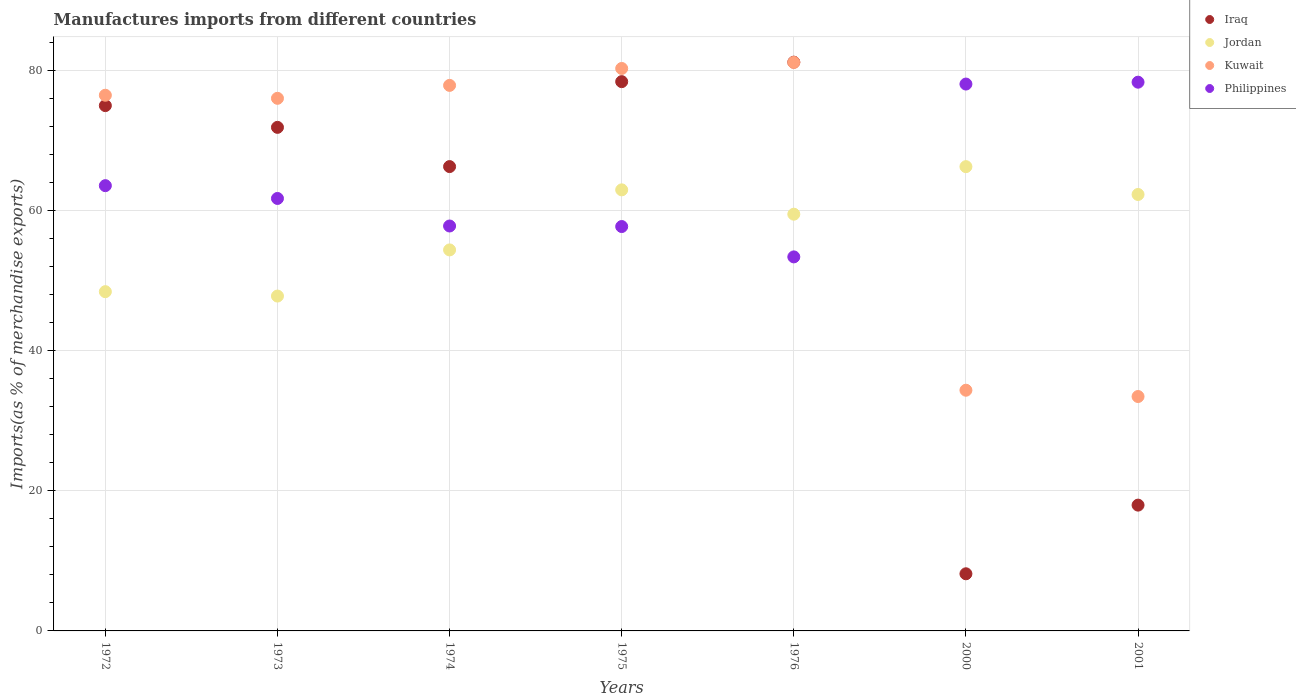How many different coloured dotlines are there?
Make the answer very short. 4. Is the number of dotlines equal to the number of legend labels?
Make the answer very short. Yes. What is the percentage of imports to different countries in Philippines in 2000?
Offer a very short reply. 78.01. Across all years, what is the maximum percentage of imports to different countries in Philippines?
Keep it short and to the point. 78.28. Across all years, what is the minimum percentage of imports to different countries in Kuwait?
Keep it short and to the point. 33.44. In which year was the percentage of imports to different countries in Jordan minimum?
Your response must be concise. 1973. What is the total percentage of imports to different countries in Kuwait in the graph?
Your response must be concise. 459.33. What is the difference between the percentage of imports to different countries in Philippines in 1974 and that in 1976?
Offer a very short reply. 4.41. What is the difference between the percentage of imports to different countries in Philippines in 1973 and the percentage of imports to different countries in Jordan in 1975?
Ensure brevity in your answer.  -1.23. What is the average percentage of imports to different countries in Philippines per year?
Make the answer very short. 64.33. In the year 1976, what is the difference between the percentage of imports to different countries in Iraq and percentage of imports to different countries in Kuwait?
Offer a terse response. 0.04. What is the ratio of the percentage of imports to different countries in Jordan in 1973 to that in 2001?
Offer a terse response. 0.77. Is the difference between the percentage of imports to different countries in Iraq in 1973 and 1976 greater than the difference between the percentage of imports to different countries in Kuwait in 1973 and 1976?
Offer a terse response. No. What is the difference between the highest and the second highest percentage of imports to different countries in Kuwait?
Offer a very short reply. 0.86. What is the difference between the highest and the lowest percentage of imports to different countries in Iraq?
Give a very brief answer. 72.99. Does the percentage of imports to different countries in Iraq monotonically increase over the years?
Your response must be concise. No. Is the percentage of imports to different countries in Iraq strictly greater than the percentage of imports to different countries in Kuwait over the years?
Give a very brief answer. No. Are the values on the major ticks of Y-axis written in scientific E-notation?
Provide a succinct answer. No. Does the graph contain grids?
Give a very brief answer. Yes. How many legend labels are there?
Offer a terse response. 4. How are the legend labels stacked?
Ensure brevity in your answer.  Vertical. What is the title of the graph?
Provide a succinct answer. Manufactures imports from different countries. What is the label or title of the Y-axis?
Your answer should be compact. Imports(as % of merchandise exports). What is the Imports(as % of merchandise exports) in Iraq in 1972?
Provide a short and direct response. 74.94. What is the Imports(as % of merchandise exports) of Jordan in 1972?
Your response must be concise. 48.4. What is the Imports(as % of merchandise exports) in Kuwait in 1972?
Make the answer very short. 76.42. What is the Imports(as % of merchandise exports) of Philippines in 1972?
Make the answer very short. 63.52. What is the Imports(as % of merchandise exports) in Iraq in 1973?
Give a very brief answer. 71.84. What is the Imports(as % of merchandise exports) of Jordan in 1973?
Keep it short and to the point. 47.77. What is the Imports(as % of merchandise exports) of Kuwait in 1973?
Ensure brevity in your answer.  75.98. What is the Imports(as % of merchandise exports) in Philippines in 1973?
Keep it short and to the point. 61.69. What is the Imports(as % of merchandise exports) in Iraq in 1974?
Your answer should be compact. 66.24. What is the Imports(as % of merchandise exports) in Jordan in 1974?
Offer a very short reply. 54.35. What is the Imports(as % of merchandise exports) in Kuwait in 1974?
Give a very brief answer. 77.82. What is the Imports(as % of merchandise exports) in Philippines in 1974?
Offer a very short reply. 57.76. What is the Imports(as % of merchandise exports) of Iraq in 1975?
Your response must be concise. 78.36. What is the Imports(as % of merchandise exports) of Jordan in 1975?
Offer a terse response. 62.92. What is the Imports(as % of merchandise exports) of Kuwait in 1975?
Offer a very short reply. 80.24. What is the Imports(as % of merchandise exports) of Philippines in 1975?
Keep it short and to the point. 57.69. What is the Imports(as % of merchandise exports) of Iraq in 1976?
Your response must be concise. 81.14. What is the Imports(as % of merchandise exports) of Jordan in 1976?
Your response must be concise. 59.45. What is the Imports(as % of merchandise exports) in Kuwait in 1976?
Your answer should be very brief. 81.1. What is the Imports(as % of merchandise exports) of Philippines in 1976?
Provide a succinct answer. 53.36. What is the Imports(as % of merchandise exports) of Iraq in 2000?
Your response must be concise. 8.15. What is the Imports(as % of merchandise exports) of Jordan in 2000?
Your answer should be compact. 66.23. What is the Imports(as % of merchandise exports) of Kuwait in 2000?
Give a very brief answer. 34.34. What is the Imports(as % of merchandise exports) in Philippines in 2000?
Offer a very short reply. 78.01. What is the Imports(as % of merchandise exports) in Iraq in 2001?
Ensure brevity in your answer.  17.95. What is the Imports(as % of merchandise exports) of Jordan in 2001?
Give a very brief answer. 62.26. What is the Imports(as % of merchandise exports) of Kuwait in 2001?
Offer a very short reply. 33.44. What is the Imports(as % of merchandise exports) in Philippines in 2001?
Provide a succinct answer. 78.28. Across all years, what is the maximum Imports(as % of merchandise exports) in Iraq?
Give a very brief answer. 81.14. Across all years, what is the maximum Imports(as % of merchandise exports) in Jordan?
Your answer should be very brief. 66.23. Across all years, what is the maximum Imports(as % of merchandise exports) in Kuwait?
Offer a very short reply. 81.1. Across all years, what is the maximum Imports(as % of merchandise exports) in Philippines?
Offer a very short reply. 78.28. Across all years, what is the minimum Imports(as % of merchandise exports) of Iraq?
Provide a succinct answer. 8.15. Across all years, what is the minimum Imports(as % of merchandise exports) in Jordan?
Your answer should be compact. 47.77. Across all years, what is the minimum Imports(as % of merchandise exports) of Kuwait?
Make the answer very short. 33.44. Across all years, what is the minimum Imports(as % of merchandise exports) of Philippines?
Give a very brief answer. 53.36. What is the total Imports(as % of merchandise exports) in Iraq in the graph?
Your response must be concise. 398.61. What is the total Imports(as % of merchandise exports) of Jordan in the graph?
Your answer should be compact. 401.38. What is the total Imports(as % of merchandise exports) in Kuwait in the graph?
Keep it short and to the point. 459.33. What is the total Imports(as % of merchandise exports) of Philippines in the graph?
Your response must be concise. 450.32. What is the difference between the Imports(as % of merchandise exports) of Iraq in 1972 and that in 1973?
Give a very brief answer. 3.1. What is the difference between the Imports(as % of merchandise exports) of Jordan in 1972 and that in 1973?
Give a very brief answer. 0.63. What is the difference between the Imports(as % of merchandise exports) of Kuwait in 1972 and that in 1973?
Ensure brevity in your answer.  0.44. What is the difference between the Imports(as % of merchandise exports) of Philippines in 1972 and that in 1973?
Offer a terse response. 1.83. What is the difference between the Imports(as % of merchandise exports) of Iraq in 1972 and that in 1974?
Offer a very short reply. 8.7. What is the difference between the Imports(as % of merchandise exports) of Jordan in 1972 and that in 1974?
Ensure brevity in your answer.  -5.96. What is the difference between the Imports(as % of merchandise exports) of Kuwait in 1972 and that in 1974?
Your answer should be compact. -1.41. What is the difference between the Imports(as % of merchandise exports) in Philippines in 1972 and that in 1974?
Provide a short and direct response. 5.75. What is the difference between the Imports(as % of merchandise exports) in Iraq in 1972 and that in 1975?
Provide a short and direct response. -3.42. What is the difference between the Imports(as % of merchandise exports) of Jordan in 1972 and that in 1975?
Your response must be concise. -14.52. What is the difference between the Imports(as % of merchandise exports) of Kuwait in 1972 and that in 1975?
Ensure brevity in your answer.  -3.82. What is the difference between the Imports(as % of merchandise exports) in Philippines in 1972 and that in 1975?
Your answer should be very brief. 5.83. What is the difference between the Imports(as % of merchandise exports) in Iraq in 1972 and that in 1976?
Your answer should be compact. -6.2. What is the difference between the Imports(as % of merchandise exports) in Jordan in 1972 and that in 1976?
Give a very brief answer. -11.05. What is the difference between the Imports(as % of merchandise exports) of Kuwait in 1972 and that in 1976?
Make the answer very short. -4.68. What is the difference between the Imports(as % of merchandise exports) in Philippines in 1972 and that in 1976?
Ensure brevity in your answer.  10.16. What is the difference between the Imports(as % of merchandise exports) of Iraq in 1972 and that in 2000?
Make the answer very short. 66.79. What is the difference between the Imports(as % of merchandise exports) of Jordan in 1972 and that in 2000?
Offer a very short reply. -17.84. What is the difference between the Imports(as % of merchandise exports) of Kuwait in 1972 and that in 2000?
Offer a terse response. 42.08. What is the difference between the Imports(as % of merchandise exports) of Philippines in 1972 and that in 2000?
Your answer should be very brief. -14.49. What is the difference between the Imports(as % of merchandise exports) of Iraq in 1972 and that in 2001?
Ensure brevity in your answer.  56.99. What is the difference between the Imports(as % of merchandise exports) of Jordan in 1972 and that in 2001?
Make the answer very short. -13.86. What is the difference between the Imports(as % of merchandise exports) in Kuwait in 1972 and that in 2001?
Give a very brief answer. 42.98. What is the difference between the Imports(as % of merchandise exports) in Philippines in 1972 and that in 2001?
Give a very brief answer. -14.76. What is the difference between the Imports(as % of merchandise exports) in Iraq in 1973 and that in 1974?
Provide a succinct answer. 5.6. What is the difference between the Imports(as % of merchandise exports) of Jordan in 1973 and that in 1974?
Give a very brief answer. -6.58. What is the difference between the Imports(as % of merchandise exports) of Kuwait in 1973 and that in 1974?
Provide a succinct answer. -1.84. What is the difference between the Imports(as % of merchandise exports) of Philippines in 1973 and that in 1974?
Ensure brevity in your answer.  3.93. What is the difference between the Imports(as % of merchandise exports) of Iraq in 1973 and that in 1975?
Make the answer very short. -6.52. What is the difference between the Imports(as % of merchandise exports) in Jordan in 1973 and that in 1975?
Make the answer very short. -15.15. What is the difference between the Imports(as % of merchandise exports) in Kuwait in 1973 and that in 1975?
Your answer should be very brief. -4.26. What is the difference between the Imports(as % of merchandise exports) in Philippines in 1973 and that in 1975?
Offer a very short reply. 4.01. What is the difference between the Imports(as % of merchandise exports) of Iraq in 1973 and that in 1976?
Offer a terse response. -9.3. What is the difference between the Imports(as % of merchandise exports) in Jordan in 1973 and that in 1976?
Ensure brevity in your answer.  -11.68. What is the difference between the Imports(as % of merchandise exports) in Kuwait in 1973 and that in 1976?
Provide a short and direct response. -5.12. What is the difference between the Imports(as % of merchandise exports) of Philippines in 1973 and that in 1976?
Your response must be concise. 8.34. What is the difference between the Imports(as % of merchandise exports) in Iraq in 1973 and that in 2000?
Keep it short and to the point. 63.69. What is the difference between the Imports(as % of merchandise exports) of Jordan in 1973 and that in 2000?
Your response must be concise. -18.46. What is the difference between the Imports(as % of merchandise exports) in Kuwait in 1973 and that in 2000?
Make the answer very short. 41.64. What is the difference between the Imports(as % of merchandise exports) of Philippines in 1973 and that in 2000?
Your answer should be very brief. -16.32. What is the difference between the Imports(as % of merchandise exports) in Iraq in 1973 and that in 2001?
Offer a very short reply. 53.89. What is the difference between the Imports(as % of merchandise exports) in Jordan in 1973 and that in 2001?
Ensure brevity in your answer.  -14.49. What is the difference between the Imports(as % of merchandise exports) of Kuwait in 1973 and that in 2001?
Provide a short and direct response. 42.54. What is the difference between the Imports(as % of merchandise exports) in Philippines in 1973 and that in 2001?
Your answer should be compact. -16.59. What is the difference between the Imports(as % of merchandise exports) in Iraq in 1974 and that in 1975?
Your answer should be compact. -12.12. What is the difference between the Imports(as % of merchandise exports) in Jordan in 1974 and that in 1975?
Your response must be concise. -8.57. What is the difference between the Imports(as % of merchandise exports) of Kuwait in 1974 and that in 1975?
Offer a terse response. -2.41. What is the difference between the Imports(as % of merchandise exports) in Philippines in 1974 and that in 1975?
Offer a very short reply. 0.08. What is the difference between the Imports(as % of merchandise exports) in Iraq in 1974 and that in 1976?
Provide a succinct answer. -14.9. What is the difference between the Imports(as % of merchandise exports) of Jordan in 1974 and that in 1976?
Keep it short and to the point. -5.1. What is the difference between the Imports(as % of merchandise exports) in Kuwait in 1974 and that in 1976?
Your answer should be compact. -3.27. What is the difference between the Imports(as % of merchandise exports) in Philippines in 1974 and that in 1976?
Make the answer very short. 4.41. What is the difference between the Imports(as % of merchandise exports) of Iraq in 1974 and that in 2000?
Your answer should be compact. 58.09. What is the difference between the Imports(as % of merchandise exports) in Jordan in 1974 and that in 2000?
Provide a succinct answer. -11.88. What is the difference between the Imports(as % of merchandise exports) of Kuwait in 1974 and that in 2000?
Give a very brief answer. 43.49. What is the difference between the Imports(as % of merchandise exports) of Philippines in 1974 and that in 2000?
Offer a very short reply. -20.25. What is the difference between the Imports(as % of merchandise exports) of Iraq in 1974 and that in 2001?
Keep it short and to the point. 48.29. What is the difference between the Imports(as % of merchandise exports) of Jordan in 1974 and that in 2001?
Your answer should be very brief. -7.91. What is the difference between the Imports(as % of merchandise exports) of Kuwait in 1974 and that in 2001?
Your response must be concise. 44.38. What is the difference between the Imports(as % of merchandise exports) of Philippines in 1974 and that in 2001?
Make the answer very short. -20.52. What is the difference between the Imports(as % of merchandise exports) of Iraq in 1975 and that in 1976?
Give a very brief answer. -2.78. What is the difference between the Imports(as % of merchandise exports) of Jordan in 1975 and that in 1976?
Offer a very short reply. 3.47. What is the difference between the Imports(as % of merchandise exports) in Kuwait in 1975 and that in 1976?
Provide a succinct answer. -0.86. What is the difference between the Imports(as % of merchandise exports) of Philippines in 1975 and that in 1976?
Your response must be concise. 4.33. What is the difference between the Imports(as % of merchandise exports) of Iraq in 1975 and that in 2000?
Give a very brief answer. 70.21. What is the difference between the Imports(as % of merchandise exports) in Jordan in 1975 and that in 2000?
Give a very brief answer. -3.31. What is the difference between the Imports(as % of merchandise exports) in Kuwait in 1975 and that in 2000?
Give a very brief answer. 45.9. What is the difference between the Imports(as % of merchandise exports) in Philippines in 1975 and that in 2000?
Offer a terse response. -20.33. What is the difference between the Imports(as % of merchandise exports) of Iraq in 1975 and that in 2001?
Keep it short and to the point. 60.41. What is the difference between the Imports(as % of merchandise exports) of Jordan in 1975 and that in 2001?
Your answer should be compact. 0.66. What is the difference between the Imports(as % of merchandise exports) of Kuwait in 1975 and that in 2001?
Offer a very short reply. 46.8. What is the difference between the Imports(as % of merchandise exports) in Philippines in 1975 and that in 2001?
Offer a very short reply. -20.59. What is the difference between the Imports(as % of merchandise exports) in Iraq in 1976 and that in 2000?
Ensure brevity in your answer.  72.99. What is the difference between the Imports(as % of merchandise exports) in Jordan in 1976 and that in 2000?
Keep it short and to the point. -6.78. What is the difference between the Imports(as % of merchandise exports) of Kuwait in 1976 and that in 2000?
Give a very brief answer. 46.76. What is the difference between the Imports(as % of merchandise exports) in Philippines in 1976 and that in 2000?
Your answer should be compact. -24.66. What is the difference between the Imports(as % of merchandise exports) in Iraq in 1976 and that in 2001?
Keep it short and to the point. 63.19. What is the difference between the Imports(as % of merchandise exports) of Jordan in 1976 and that in 2001?
Ensure brevity in your answer.  -2.81. What is the difference between the Imports(as % of merchandise exports) of Kuwait in 1976 and that in 2001?
Give a very brief answer. 47.66. What is the difference between the Imports(as % of merchandise exports) in Philippines in 1976 and that in 2001?
Provide a succinct answer. -24.92. What is the difference between the Imports(as % of merchandise exports) in Iraq in 2000 and that in 2001?
Offer a terse response. -9.79. What is the difference between the Imports(as % of merchandise exports) in Jordan in 2000 and that in 2001?
Your answer should be very brief. 3.97. What is the difference between the Imports(as % of merchandise exports) of Kuwait in 2000 and that in 2001?
Your answer should be compact. 0.9. What is the difference between the Imports(as % of merchandise exports) in Philippines in 2000 and that in 2001?
Ensure brevity in your answer.  -0.27. What is the difference between the Imports(as % of merchandise exports) in Iraq in 1972 and the Imports(as % of merchandise exports) in Jordan in 1973?
Make the answer very short. 27.17. What is the difference between the Imports(as % of merchandise exports) of Iraq in 1972 and the Imports(as % of merchandise exports) of Kuwait in 1973?
Offer a very short reply. -1.04. What is the difference between the Imports(as % of merchandise exports) of Iraq in 1972 and the Imports(as % of merchandise exports) of Philippines in 1973?
Give a very brief answer. 13.24. What is the difference between the Imports(as % of merchandise exports) in Jordan in 1972 and the Imports(as % of merchandise exports) in Kuwait in 1973?
Give a very brief answer. -27.58. What is the difference between the Imports(as % of merchandise exports) of Jordan in 1972 and the Imports(as % of merchandise exports) of Philippines in 1973?
Offer a terse response. -13.3. What is the difference between the Imports(as % of merchandise exports) of Kuwait in 1972 and the Imports(as % of merchandise exports) of Philippines in 1973?
Keep it short and to the point. 14.72. What is the difference between the Imports(as % of merchandise exports) in Iraq in 1972 and the Imports(as % of merchandise exports) in Jordan in 1974?
Your answer should be very brief. 20.59. What is the difference between the Imports(as % of merchandise exports) in Iraq in 1972 and the Imports(as % of merchandise exports) in Kuwait in 1974?
Your response must be concise. -2.88. What is the difference between the Imports(as % of merchandise exports) of Iraq in 1972 and the Imports(as % of merchandise exports) of Philippines in 1974?
Offer a terse response. 17.17. What is the difference between the Imports(as % of merchandise exports) of Jordan in 1972 and the Imports(as % of merchandise exports) of Kuwait in 1974?
Provide a short and direct response. -29.43. What is the difference between the Imports(as % of merchandise exports) in Jordan in 1972 and the Imports(as % of merchandise exports) in Philippines in 1974?
Offer a very short reply. -9.37. What is the difference between the Imports(as % of merchandise exports) of Kuwait in 1972 and the Imports(as % of merchandise exports) of Philippines in 1974?
Your response must be concise. 18.65. What is the difference between the Imports(as % of merchandise exports) of Iraq in 1972 and the Imports(as % of merchandise exports) of Jordan in 1975?
Provide a succinct answer. 12.02. What is the difference between the Imports(as % of merchandise exports) in Iraq in 1972 and the Imports(as % of merchandise exports) in Kuwait in 1975?
Make the answer very short. -5.3. What is the difference between the Imports(as % of merchandise exports) of Iraq in 1972 and the Imports(as % of merchandise exports) of Philippines in 1975?
Provide a succinct answer. 17.25. What is the difference between the Imports(as % of merchandise exports) in Jordan in 1972 and the Imports(as % of merchandise exports) in Kuwait in 1975?
Your response must be concise. -31.84. What is the difference between the Imports(as % of merchandise exports) in Jordan in 1972 and the Imports(as % of merchandise exports) in Philippines in 1975?
Make the answer very short. -9.29. What is the difference between the Imports(as % of merchandise exports) in Kuwait in 1972 and the Imports(as % of merchandise exports) in Philippines in 1975?
Ensure brevity in your answer.  18.73. What is the difference between the Imports(as % of merchandise exports) of Iraq in 1972 and the Imports(as % of merchandise exports) of Jordan in 1976?
Offer a terse response. 15.49. What is the difference between the Imports(as % of merchandise exports) of Iraq in 1972 and the Imports(as % of merchandise exports) of Kuwait in 1976?
Your answer should be very brief. -6.16. What is the difference between the Imports(as % of merchandise exports) in Iraq in 1972 and the Imports(as % of merchandise exports) in Philippines in 1976?
Provide a short and direct response. 21.58. What is the difference between the Imports(as % of merchandise exports) of Jordan in 1972 and the Imports(as % of merchandise exports) of Kuwait in 1976?
Your response must be concise. -32.7. What is the difference between the Imports(as % of merchandise exports) of Jordan in 1972 and the Imports(as % of merchandise exports) of Philippines in 1976?
Your response must be concise. -4.96. What is the difference between the Imports(as % of merchandise exports) of Kuwait in 1972 and the Imports(as % of merchandise exports) of Philippines in 1976?
Ensure brevity in your answer.  23.06. What is the difference between the Imports(as % of merchandise exports) in Iraq in 1972 and the Imports(as % of merchandise exports) in Jordan in 2000?
Your answer should be very brief. 8.71. What is the difference between the Imports(as % of merchandise exports) in Iraq in 1972 and the Imports(as % of merchandise exports) in Kuwait in 2000?
Your answer should be compact. 40.6. What is the difference between the Imports(as % of merchandise exports) in Iraq in 1972 and the Imports(as % of merchandise exports) in Philippines in 2000?
Keep it short and to the point. -3.07. What is the difference between the Imports(as % of merchandise exports) of Jordan in 1972 and the Imports(as % of merchandise exports) of Kuwait in 2000?
Give a very brief answer. 14.06. What is the difference between the Imports(as % of merchandise exports) of Jordan in 1972 and the Imports(as % of merchandise exports) of Philippines in 2000?
Ensure brevity in your answer.  -29.62. What is the difference between the Imports(as % of merchandise exports) of Kuwait in 1972 and the Imports(as % of merchandise exports) of Philippines in 2000?
Ensure brevity in your answer.  -1.6. What is the difference between the Imports(as % of merchandise exports) in Iraq in 1972 and the Imports(as % of merchandise exports) in Jordan in 2001?
Offer a terse response. 12.68. What is the difference between the Imports(as % of merchandise exports) of Iraq in 1972 and the Imports(as % of merchandise exports) of Kuwait in 2001?
Make the answer very short. 41.5. What is the difference between the Imports(as % of merchandise exports) in Iraq in 1972 and the Imports(as % of merchandise exports) in Philippines in 2001?
Give a very brief answer. -3.34. What is the difference between the Imports(as % of merchandise exports) of Jordan in 1972 and the Imports(as % of merchandise exports) of Kuwait in 2001?
Ensure brevity in your answer.  14.96. What is the difference between the Imports(as % of merchandise exports) in Jordan in 1972 and the Imports(as % of merchandise exports) in Philippines in 2001?
Ensure brevity in your answer.  -29.88. What is the difference between the Imports(as % of merchandise exports) of Kuwait in 1972 and the Imports(as % of merchandise exports) of Philippines in 2001?
Provide a succinct answer. -1.86. What is the difference between the Imports(as % of merchandise exports) in Iraq in 1973 and the Imports(as % of merchandise exports) in Jordan in 1974?
Give a very brief answer. 17.48. What is the difference between the Imports(as % of merchandise exports) in Iraq in 1973 and the Imports(as % of merchandise exports) in Kuwait in 1974?
Offer a terse response. -5.99. What is the difference between the Imports(as % of merchandise exports) in Iraq in 1973 and the Imports(as % of merchandise exports) in Philippines in 1974?
Ensure brevity in your answer.  14.07. What is the difference between the Imports(as % of merchandise exports) of Jordan in 1973 and the Imports(as % of merchandise exports) of Kuwait in 1974?
Your response must be concise. -30.05. What is the difference between the Imports(as % of merchandise exports) of Jordan in 1973 and the Imports(as % of merchandise exports) of Philippines in 1974?
Give a very brief answer. -9.99. What is the difference between the Imports(as % of merchandise exports) of Kuwait in 1973 and the Imports(as % of merchandise exports) of Philippines in 1974?
Your answer should be very brief. 18.22. What is the difference between the Imports(as % of merchandise exports) of Iraq in 1973 and the Imports(as % of merchandise exports) of Jordan in 1975?
Offer a very short reply. 8.92. What is the difference between the Imports(as % of merchandise exports) of Iraq in 1973 and the Imports(as % of merchandise exports) of Kuwait in 1975?
Ensure brevity in your answer.  -8.4. What is the difference between the Imports(as % of merchandise exports) in Iraq in 1973 and the Imports(as % of merchandise exports) in Philippines in 1975?
Keep it short and to the point. 14.15. What is the difference between the Imports(as % of merchandise exports) of Jordan in 1973 and the Imports(as % of merchandise exports) of Kuwait in 1975?
Keep it short and to the point. -32.47. What is the difference between the Imports(as % of merchandise exports) of Jordan in 1973 and the Imports(as % of merchandise exports) of Philippines in 1975?
Give a very brief answer. -9.92. What is the difference between the Imports(as % of merchandise exports) of Kuwait in 1973 and the Imports(as % of merchandise exports) of Philippines in 1975?
Make the answer very short. 18.29. What is the difference between the Imports(as % of merchandise exports) of Iraq in 1973 and the Imports(as % of merchandise exports) of Jordan in 1976?
Your response must be concise. 12.39. What is the difference between the Imports(as % of merchandise exports) of Iraq in 1973 and the Imports(as % of merchandise exports) of Kuwait in 1976?
Give a very brief answer. -9.26. What is the difference between the Imports(as % of merchandise exports) in Iraq in 1973 and the Imports(as % of merchandise exports) in Philippines in 1976?
Keep it short and to the point. 18.48. What is the difference between the Imports(as % of merchandise exports) in Jordan in 1973 and the Imports(as % of merchandise exports) in Kuwait in 1976?
Your answer should be very brief. -33.33. What is the difference between the Imports(as % of merchandise exports) in Jordan in 1973 and the Imports(as % of merchandise exports) in Philippines in 1976?
Your answer should be compact. -5.59. What is the difference between the Imports(as % of merchandise exports) of Kuwait in 1973 and the Imports(as % of merchandise exports) of Philippines in 1976?
Your answer should be very brief. 22.62. What is the difference between the Imports(as % of merchandise exports) of Iraq in 1973 and the Imports(as % of merchandise exports) of Jordan in 2000?
Your answer should be compact. 5.6. What is the difference between the Imports(as % of merchandise exports) of Iraq in 1973 and the Imports(as % of merchandise exports) of Kuwait in 2000?
Your answer should be compact. 37.5. What is the difference between the Imports(as % of merchandise exports) of Iraq in 1973 and the Imports(as % of merchandise exports) of Philippines in 2000?
Your answer should be compact. -6.18. What is the difference between the Imports(as % of merchandise exports) of Jordan in 1973 and the Imports(as % of merchandise exports) of Kuwait in 2000?
Provide a succinct answer. 13.43. What is the difference between the Imports(as % of merchandise exports) of Jordan in 1973 and the Imports(as % of merchandise exports) of Philippines in 2000?
Offer a very short reply. -30.24. What is the difference between the Imports(as % of merchandise exports) of Kuwait in 1973 and the Imports(as % of merchandise exports) of Philippines in 2000?
Offer a terse response. -2.03. What is the difference between the Imports(as % of merchandise exports) in Iraq in 1973 and the Imports(as % of merchandise exports) in Jordan in 2001?
Provide a succinct answer. 9.58. What is the difference between the Imports(as % of merchandise exports) in Iraq in 1973 and the Imports(as % of merchandise exports) in Kuwait in 2001?
Make the answer very short. 38.4. What is the difference between the Imports(as % of merchandise exports) in Iraq in 1973 and the Imports(as % of merchandise exports) in Philippines in 2001?
Give a very brief answer. -6.44. What is the difference between the Imports(as % of merchandise exports) in Jordan in 1973 and the Imports(as % of merchandise exports) in Kuwait in 2001?
Give a very brief answer. 14.33. What is the difference between the Imports(as % of merchandise exports) of Jordan in 1973 and the Imports(as % of merchandise exports) of Philippines in 2001?
Provide a short and direct response. -30.51. What is the difference between the Imports(as % of merchandise exports) of Kuwait in 1973 and the Imports(as % of merchandise exports) of Philippines in 2001?
Your answer should be compact. -2.3. What is the difference between the Imports(as % of merchandise exports) in Iraq in 1974 and the Imports(as % of merchandise exports) in Jordan in 1975?
Your response must be concise. 3.32. What is the difference between the Imports(as % of merchandise exports) of Iraq in 1974 and the Imports(as % of merchandise exports) of Kuwait in 1975?
Offer a terse response. -14. What is the difference between the Imports(as % of merchandise exports) in Iraq in 1974 and the Imports(as % of merchandise exports) in Philippines in 1975?
Your response must be concise. 8.55. What is the difference between the Imports(as % of merchandise exports) in Jordan in 1974 and the Imports(as % of merchandise exports) in Kuwait in 1975?
Keep it short and to the point. -25.88. What is the difference between the Imports(as % of merchandise exports) in Jordan in 1974 and the Imports(as % of merchandise exports) in Philippines in 1975?
Provide a short and direct response. -3.33. What is the difference between the Imports(as % of merchandise exports) in Kuwait in 1974 and the Imports(as % of merchandise exports) in Philippines in 1975?
Provide a succinct answer. 20.14. What is the difference between the Imports(as % of merchandise exports) of Iraq in 1974 and the Imports(as % of merchandise exports) of Jordan in 1976?
Your response must be concise. 6.79. What is the difference between the Imports(as % of merchandise exports) in Iraq in 1974 and the Imports(as % of merchandise exports) in Kuwait in 1976?
Your answer should be compact. -14.86. What is the difference between the Imports(as % of merchandise exports) in Iraq in 1974 and the Imports(as % of merchandise exports) in Philippines in 1976?
Your answer should be compact. 12.88. What is the difference between the Imports(as % of merchandise exports) in Jordan in 1974 and the Imports(as % of merchandise exports) in Kuwait in 1976?
Your response must be concise. -26.74. What is the difference between the Imports(as % of merchandise exports) of Jordan in 1974 and the Imports(as % of merchandise exports) of Philippines in 1976?
Your response must be concise. 0.99. What is the difference between the Imports(as % of merchandise exports) of Kuwait in 1974 and the Imports(as % of merchandise exports) of Philippines in 1976?
Your response must be concise. 24.47. What is the difference between the Imports(as % of merchandise exports) in Iraq in 1974 and the Imports(as % of merchandise exports) in Jordan in 2000?
Provide a succinct answer. 0.01. What is the difference between the Imports(as % of merchandise exports) in Iraq in 1974 and the Imports(as % of merchandise exports) in Kuwait in 2000?
Provide a succinct answer. 31.9. What is the difference between the Imports(as % of merchandise exports) in Iraq in 1974 and the Imports(as % of merchandise exports) in Philippines in 2000?
Give a very brief answer. -11.77. What is the difference between the Imports(as % of merchandise exports) of Jordan in 1974 and the Imports(as % of merchandise exports) of Kuwait in 2000?
Ensure brevity in your answer.  20.02. What is the difference between the Imports(as % of merchandise exports) of Jordan in 1974 and the Imports(as % of merchandise exports) of Philippines in 2000?
Ensure brevity in your answer.  -23.66. What is the difference between the Imports(as % of merchandise exports) of Kuwait in 1974 and the Imports(as % of merchandise exports) of Philippines in 2000?
Offer a very short reply. -0.19. What is the difference between the Imports(as % of merchandise exports) in Iraq in 1974 and the Imports(as % of merchandise exports) in Jordan in 2001?
Provide a short and direct response. 3.98. What is the difference between the Imports(as % of merchandise exports) in Iraq in 1974 and the Imports(as % of merchandise exports) in Kuwait in 2001?
Keep it short and to the point. 32.8. What is the difference between the Imports(as % of merchandise exports) of Iraq in 1974 and the Imports(as % of merchandise exports) of Philippines in 2001?
Give a very brief answer. -12.04. What is the difference between the Imports(as % of merchandise exports) in Jordan in 1974 and the Imports(as % of merchandise exports) in Kuwait in 2001?
Ensure brevity in your answer.  20.91. What is the difference between the Imports(as % of merchandise exports) in Jordan in 1974 and the Imports(as % of merchandise exports) in Philippines in 2001?
Ensure brevity in your answer.  -23.93. What is the difference between the Imports(as % of merchandise exports) of Kuwait in 1974 and the Imports(as % of merchandise exports) of Philippines in 2001?
Give a very brief answer. -0.46. What is the difference between the Imports(as % of merchandise exports) of Iraq in 1975 and the Imports(as % of merchandise exports) of Jordan in 1976?
Make the answer very short. 18.91. What is the difference between the Imports(as % of merchandise exports) of Iraq in 1975 and the Imports(as % of merchandise exports) of Kuwait in 1976?
Ensure brevity in your answer.  -2.74. What is the difference between the Imports(as % of merchandise exports) of Iraq in 1975 and the Imports(as % of merchandise exports) of Philippines in 1976?
Your answer should be very brief. 25. What is the difference between the Imports(as % of merchandise exports) in Jordan in 1975 and the Imports(as % of merchandise exports) in Kuwait in 1976?
Provide a short and direct response. -18.18. What is the difference between the Imports(as % of merchandise exports) of Jordan in 1975 and the Imports(as % of merchandise exports) of Philippines in 1976?
Offer a very short reply. 9.56. What is the difference between the Imports(as % of merchandise exports) of Kuwait in 1975 and the Imports(as % of merchandise exports) of Philippines in 1976?
Give a very brief answer. 26.88. What is the difference between the Imports(as % of merchandise exports) of Iraq in 1975 and the Imports(as % of merchandise exports) of Jordan in 2000?
Keep it short and to the point. 12.13. What is the difference between the Imports(as % of merchandise exports) of Iraq in 1975 and the Imports(as % of merchandise exports) of Kuwait in 2000?
Your answer should be compact. 44.02. What is the difference between the Imports(as % of merchandise exports) in Iraq in 1975 and the Imports(as % of merchandise exports) in Philippines in 2000?
Offer a terse response. 0.34. What is the difference between the Imports(as % of merchandise exports) in Jordan in 1975 and the Imports(as % of merchandise exports) in Kuwait in 2000?
Ensure brevity in your answer.  28.58. What is the difference between the Imports(as % of merchandise exports) in Jordan in 1975 and the Imports(as % of merchandise exports) in Philippines in 2000?
Provide a short and direct response. -15.09. What is the difference between the Imports(as % of merchandise exports) of Kuwait in 1975 and the Imports(as % of merchandise exports) of Philippines in 2000?
Your answer should be very brief. 2.22. What is the difference between the Imports(as % of merchandise exports) in Iraq in 1975 and the Imports(as % of merchandise exports) in Jordan in 2001?
Your answer should be very brief. 16.1. What is the difference between the Imports(as % of merchandise exports) in Iraq in 1975 and the Imports(as % of merchandise exports) in Kuwait in 2001?
Your answer should be very brief. 44.92. What is the difference between the Imports(as % of merchandise exports) of Iraq in 1975 and the Imports(as % of merchandise exports) of Philippines in 2001?
Keep it short and to the point. 0.08. What is the difference between the Imports(as % of merchandise exports) in Jordan in 1975 and the Imports(as % of merchandise exports) in Kuwait in 2001?
Provide a short and direct response. 29.48. What is the difference between the Imports(as % of merchandise exports) of Jordan in 1975 and the Imports(as % of merchandise exports) of Philippines in 2001?
Make the answer very short. -15.36. What is the difference between the Imports(as % of merchandise exports) of Kuwait in 1975 and the Imports(as % of merchandise exports) of Philippines in 2001?
Keep it short and to the point. 1.96. What is the difference between the Imports(as % of merchandise exports) of Iraq in 1976 and the Imports(as % of merchandise exports) of Jordan in 2000?
Your answer should be compact. 14.91. What is the difference between the Imports(as % of merchandise exports) of Iraq in 1976 and the Imports(as % of merchandise exports) of Kuwait in 2000?
Make the answer very short. 46.8. What is the difference between the Imports(as % of merchandise exports) of Iraq in 1976 and the Imports(as % of merchandise exports) of Philippines in 2000?
Your answer should be compact. 3.12. What is the difference between the Imports(as % of merchandise exports) in Jordan in 1976 and the Imports(as % of merchandise exports) in Kuwait in 2000?
Your answer should be compact. 25.11. What is the difference between the Imports(as % of merchandise exports) of Jordan in 1976 and the Imports(as % of merchandise exports) of Philippines in 2000?
Ensure brevity in your answer.  -18.56. What is the difference between the Imports(as % of merchandise exports) in Kuwait in 1976 and the Imports(as % of merchandise exports) in Philippines in 2000?
Ensure brevity in your answer.  3.08. What is the difference between the Imports(as % of merchandise exports) in Iraq in 1976 and the Imports(as % of merchandise exports) in Jordan in 2001?
Make the answer very short. 18.88. What is the difference between the Imports(as % of merchandise exports) of Iraq in 1976 and the Imports(as % of merchandise exports) of Kuwait in 2001?
Ensure brevity in your answer.  47.7. What is the difference between the Imports(as % of merchandise exports) in Iraq in 1976 and the Imports(as % of merchandise exports) in Philippines in 2001?
Keep it short and to the point. 2.86. What is the difference between the Imports(as % of merchandise exports) of Jordan in 1976 and the Imports(as % of merchandise exports) of Kuwait in 2001?
Provide a succinct answer. 26.01. What is the difference between the Imports(as % of merchandise exports) of Jordan in 1976 and the Imports(as % of merchandise exports) of Philippines in 2001?
Ensure brevity in your answer.  -18.83. What is the difference between the Imports(as % of merchandise exports) in Kuwait in 1976 and the Imports(as % of merchandise exports) in Philippines in 2001?
Your answer should be very brief. 2.82. What is the difference between the Imports(as % of merchandise exports) of Iraq in 2000 and the Imports(as % of merchandise exports) of Jordan in 2001?
Give a very brief answer. -54.11. What is the difference between the Imports(as % of merchandise exports) of Iraq in 2000 and the Imports(as % of merchandise exports) of Kuwait in 2001?
Make the answer very short. -25.29. What is the difference between the Imports(as % of merchandise exports) of Iraq in 2000 and the Imports(as % of merchandise exports) of Philippines in 2001?
Keep it short and to the point. -70.13. What is the difference between the Imports(as % of merchandise exports) in Jordan in 2000 and the Imports(as % of merchandise exports) in Kuwait in 2001?
Offer a terse response. 32.79. What is the difference between the Imports(as % of merchandise exports) in Jordan in 2000 and the Imports(as % of merchandise exports) in Philippines in 2001?
Provide a succinct answer. -12.05. What is the difference between the Imports(as % of merchandise exports) in Kuwait in 2000 and the Imports(as % of merchandise exports) in Philippines in 2001?
Ensure brevity in your answer.  -43.94. What is the average Imports(as % of merchandise exports) in Iraq per year?
Make the answer very short. 56.94. What is the average Imports(as % of merchandise exports) of Jordan per year?
Your response must be concise. 57.34. What is the average Imports(as % of merchandise exports) of Kuwait per year?
Your answer should be compact. 65.62. What is the average Imports(as % of merchandise exports) of Philippines per year?
Your answer should be very brief. 64.33. In the year 1972, what is the difference between the Imports(as % of merchandise exports) of Iraq and Imports(as % of merchandise exports) of Jordan?
Give a very brief answer. 26.54. In the year 1972, what is the difference between the Imports(as % of merchandise exports) of Iraq and Imports(as % of merchandise exports) of Kuwait?
Give a very brief answer. -1.48. In the year 1972, what is the difference between the Imports(as % of merchandise exports) in Iraq and Imports(as % of merchandise exports) in Philippines?
Your response must be concise. 11.42. In the year 1972, what is the difference between the Imports(as % of merchandise exports) in Jordan and Imports(as % of merchandise exports) in Kuwait?
Make the answer very short. -28.02. In the year 1972, what is the difference between the Imports(as % of merchandise exports) of Jordan and Imports(as % of merchandise exports) of Philippines?
Provide a succinct answer. -15.12. In the year 1972, what is the difference between the Imports(as % of merchandise exports) of Kuwait and Imports(as % of merchandise exports) of Philippines?
Offer a terse response. 12.9. In the year 1973, what is the difference between the Imports(as % of merchandise exports) of Iraq and Imports(as % of merchandise exports) of Jordan?
Offer a very short reply. 24.07. In the year 1973, what is the difference between the Imports(as % of merchandise exports) of Iraq and Imports(as % of merchandise exports) of Kuwait?
Provide a short and direct response. -4.14. In the year 1973, what is the difference between the Imports(as % of merchandise exports) in Iraq and Imports(as % of merchandise exports) in Philippines?
Keep it short and to the point. 10.14. In the year 1973, what is the difference between the Imports(as % of merchandise exports) in Jordan and Imports(as % of merchandise exports) in Kuwait?
Your answer should be very brief. -28.21. In the year 1973, what is the difference between the Imports(as % of merchandise exports) of Jordan and Imports(as % of merchandise exports) of Philippines?
Your response must be concise. -13.92. In the year 1973, what is the difference between the Imports(as % of merchandise exports) of Kuwait and Imports(as % of merchandise exports) of Philippines?
Keep it short and to the point. 14.29. In the year 1974, what is the difference between the Imports(as % of merchandise exports) of Iraq and Imports(as % of merchandise exports) of Jordan?
Provide a short and direct response. 11.89. In the year 1974, what is the difference between the Imports(as % of merchandise exports) of Iraq and Imports(as % of merchandise exports) of Kuwait?
Ensure brevity in your answer.  -11.58. In the year 1974, what is the difference between the Imports(as % of merchandise exports) in Iraq and Imports(as % of merchandise exports) in Philippines?
Give a very brief answer. 8.48. In the year 1974, what is the difference between the Imports(as % of merchandise exports) in Jordan and Imports(as % of merchandise exports) in Kuwait?
Your response must be concise. -23.47. In the year 1974, what is the difference between the Imports(as % of merchandise exports) of Jordan and Imports(as % of merchandise exports) of Philippines?
Provide a short and direct response. -3.41. In the year 1974, what is the difference between the Imports(as % of merchandise exports) in Kuwait and Imports(as % of merchandise exports) in Philippines?
Provide a succinct answer. 20.06. In the year 1975, what is the difference between the Imports(as % of merchandise exports) in Iraq and Imports(as % of merchandise exports) in Jordan?
Make the answer very short. 15.44. In the year 1975, what is the difference between the Imports(as % of merchandise exports) in Iraq and Imports(as % of merchandise exports) in Kuwait?
Offer a very short reply. -1.88. In the year 1975, what is the difference between the Imports(as % of merchandise exports) in Iraq and Imports(as % of merchandise exports) in Philippines?
Offer a very short reply. 20.67. In the year 1975, what is the difference between the Imports(as % of merchandise exports) of Jordan and Imports(as % of merchandise exports) of Kuwait?
Ensure brevity in your answer.  -17.32. In the year 1975, what is the difference between the Imports(as % of merchandise exports) in Jordan and Imports(as % of merchandise exports) in Philippines?
Provide a succinct answer. 5.23. In the year 1975, what is the difference between the Imports(as % of merchandise exports) in Kuwait and Imports(as % of merchandise exports) in Philippines?
Offer a very short reply. 22.55. In the year 1976, what is the difference between the Imports(as % of merchandise exports) in Iraq and Imports(as % of merchandise exports) in Jordan?
Give a very brief answer. 21.69. In the year 1976, what is the difference between the Imports(as % of merchandise exports) in Iraq and Imports(as % of merchandise exports) in Kuwait?
Ensure brevity in your answer.  0.04. In the year 1976, what is the difference between the Imports(as % of merchandise exports) of Iraq and Imports(as % of merchandise exports) of Philippines?
Offer a terse response. 27.78. In the year 1976, what is the difference between the Imports(as % of merchandise exports) in Jordan and Imports(as % of merchandise exports) in Kuwait?
Keep it short and to the point. -21.65. In the year 1976, what is the difference between the Imports(as % of merchandise exports) of Jordan and Imports(as % of merchandise exports) of Philippines?
Your answer should be very brief. 6.09. In the year 1976, what is the difference between the Imports(as % of merchandise exports) in Kuwait and Imports(as % of merchandise exports) in Philippines?
Your answer should be very brief. 27.74. In the year 2000, what is the difference between the Imports(as % of merchandise exports) in Iraq and Imports(as % of merchandise exports) in Jordan?
Offer a terse response. -58.08. In the year 2000, what is the difference between the Imports(as % of merchandise exports) in Iraq and Imports(as % of merchandise exports) in Kuwait?
Make the answer very short. -26.19. In the year 2000, what is the difference between the Imports(as % of merchandise exports) of Iraq and Imports(as % of merchandise exports) of Philippines?
Keep it short and to the point. -69.86. In the year 2000, what is the difference between the Imports(as % of merchandise exports) in Jordan and Imports(as % of merchandise exports) in Kuwait?
Your response must be concise. 31.9. In the year 2000, what is the difference between the Imports(as % of merchandise exports) of Jordan and Imports(as % of merchandise exports) of Philippines?
Keep it short and to the point. -11.78. In the year 2000, what is the difference between the Imports(as % of merchandise exports) of Kuwait and Imports(as % of merchandise exports) of Philippines?
Keep it short and to the point. -43.68. In the year 2001, what is the difference between the Imports(as % of merchandise exports) in Iraq and Imports(as % of merchandise exports) in Jordan?
Provide a succinct answer. -44.32. In the year 2001, what is the difference between the Imports(as % of merchandise exports) of Iraq and Imports(as % of merchandise exports) of Kuwait?
Your answer should be compact. -15.49. In the year 2001, what is the difference between the Imports(as % of merchandise exports) in Iraq and Imports(as % of merchandise exports) in Philippines?
Offer a very short reply. -60.34. In the year 2001, what is the difference between the Imports(as % of merchandise exports) of Jordan and Imports(as % of merchandise exports) of Kuwait?
Provide a short and direct response. 28.82. In the year 2001, what is the difference between the Imports(as % of merchandise exports) in Jordan and Imports(as % of merchandise exports) in Philippines?
Make the answer very short. -16.02. In the year 2001, what is the difference between the Imports(as % of merchandise exports) in Kuwait and Imports(as % of merchandise exports) in Philippines?
Provide a short and direct response. -44.84. What is the ratio of the Imports(as % of merchandise exports) in Iraq in 1972 to that in 1973?
Your response must be concise. 1.04. What is the ratio of the Imports(as % of merchandise exports) in Jordan in 1972 to that in 1973?
Make the answer very short. 1.01. What is the ratio of the Imports(as % of merchandise exports) of Philippines in 1972 to that in 1973?
Your answer should be compact. 1.03. What is the ratio of the Imports(as % of merchandise exports) of Iraq in 1972 to that in 1974?
Offer a very short reply. 1.13. What is the ratio of the Imports(as % of merchandise exports) of Jordan in 1972 to that in 1974?
Provide a short and direct response. 0.89. What is the ratio of the Imports(as % of merchandise exports) of Kuwait in 1972 to that in 1974?
Make the answer very short. 0.98. What is the ratio of the Imports(as % of merchandise exports) of Philippines in 1972 to that in 1974?
Keep it short and to the point. 1.1. What is the ratio of the Imports(as % of merchandise exports) of Iraq in 1972 to that in 1975?
Make the answer very short. 0.96. What is the ratio of the Imports(as % of merchandise exports) of Jordan in 1972 to that in 1975?
Offer a very short reply. 0.77. What is the ratio of the Imports(as % of merchandise exports) in Kuwait in 1972 to that in 1975?
Give a very brief answer. 0.95. What is the ratio of the Imports(as % of merchandise exports) of Philippines in 1972 to that in 1975?
Your response must be concise. 1.1. What is the ratio of the Imports(as % of merchandise exports) in Iraq in 1972 to that in 1976?
Your answer should be compact. 0.92. What is the ratio of the Imports(as % of merchandise exports) of Jordan in 1972 to that in 1976?
Your answer should be compact. 0.81. What is the ratio of the Imports(as % of merchandise exports) in Kuwait in 1972 to that in 1976?
Offer a terse response. 0.94. What is the ratio of the Imports(as % of merchandise exports) in Philippines in 1972 to that in 1976?
Give a very brief answer. 1.19. What is the ratio of the Imports(as % of merchandise exports) in Iraq in 1972 to that in 2000?
Keep it short and to the point. 9.19. What is the ratio of the Imports(as % of merchandise exports) of Jordan in 1972 to that in 2000?
Offer a very short reply. 0.73. What is the ratio of the Imports(as % of merchandise exports) in Kuwait in 1972 to that in 2000?
Provide a succinct answer. 2.23. What is the ratio of the Imports(as % of merchandise exports) in Philippines in 1972 to that in 2000?
Keep it short and to the point. 0.81. What is the ratio of the Imports(as % of merchandise exports) in Iraq in 1972 to that in 2001?
Your answer should be very brief. 4.18. What is the ratio of the Imports(as % of merchandise exports) in Jordan in 1972 to that in 2001?
Offer a very short reply. 0.78. What is the ratio of the Imports(as % of merchandise exports) in Kuwait in 1972 to that in 2001?
Your response must be concise. 2.29. What is the ratio of the Imports(as % of merchandise exports) in Philippines in 1972 to that in 2001?
Give a very brief answer. 0.81. What is the ratio of the Imports(as % of merchandise exports) of Iraq in 1973 to that in 1974?
Keep it short and to the point. 1.08. What is the ratio of the Imports(as % of merchandise exports) of Jordan in 1973 to that in 1974?
Your answer should be very brief. 0.88. What is the ratio of the Imports(as % of merchandise exports) of Kuwait in 1973 to that in 1974?
Your answer should be very brief. 0.98. What is the ratio of the Imports(as % of merchandise exports) in Philippines in 1973 to that in 1974?
Keep it short and to the point. 1.07. What is the ratio of the Imports(as % of merchandise exports) of Iraq in 1973 to that in 1975?
Provide a succinct answer. 0.92. What is the ratio of the Imports(as % of merchandise exports) in Jordan in 1973 to that in 1975?
Offer a terse response. 0.76. What is the ratio of the Imports(as % of merchandise exports) in Kuwait in 1973 to that in 1975?
Provide a short and direct response. 0.95. What is the ratio of the Imports(as % of merchandise exports) in Philippines in 1973 to that in 1975?
Your answer should be very brief. 1.07. What is the ratio of the Imports(as % of merchandise exports) in Iraq in 1973 to that in 1976?
Provide a short and direct response. 0.89. What is the ratio of the Imports(as % of merchandise exports) in Jordan in 1973 to that in 1976?
Offer a very short reply. 0.8. What is the ratio of the Imports(as % of merchandise exports) of Kuwait in 1973 to that in 1976?
Ensure brevity in your answer.  0.94. What is the ratio of the Imports(as % of merchandise exports) of Philippines in 1973 to that in 1976?
Make the answer very short. 1.16. What is the ratio of the Imports(as % of merchandise exports) in Iraq in 1973 to that in 2000?
Your answer should be compact. 8.81. What is the ratio of the Imports(as % of merchandise exports) of Jordan in 1973 to that in 2000?
Your answer should be very brief. 0.72. What is the ratio of the Imports(as % of merchandise exports) of Kuwait in 1973 to that in 2000?
Your answer should be compact. 2.21. What is the ratio of the Imports(as % of merchandise exports) of Philippines in 1973 to that in 2000?
Keep it short and to the point. 0.79. What is the ratio of the Imports(as % of merchandise exports) of Iraq in 1973 to that in 2001?
Your response must be concise. 4. What is the ratio of the Imports(as % of merchandise exports) in Jordan in 1973 to that in 2001?
Your answer should be very brief. 0.77. What is the ratio of the Imports(as % of merchandise exports) in Kuwait in 1973 to that in 2001?
Provide a succinct answer. 2.27. What is the ratio of the Imports(as % of merchandise exports) of Philippines in 1973 to that in 2001?
Your response must be concise. 0.79. What is the ratio of the Imports(as % of merchandise exports) in Iraq in 1974 to that in 1975?
Provide a succinct answer. 0.85. What is the ratio of the Imports(as % of merchandise exports) in Jordan in 1974 to that in 1975?
Keep it short and to the point. 0.86. What is the ratio of the Imports(as % of merchandise exports) of Kuwait in 1974 to that in 1975?
Provide a short and direct response. 0.97. What is the ratio of the Imports(as % of merchandise exports) in Iraq in 1974 to that in 1976?
Give a very brief answer. 0.82. What is the ratio of the Imports(as % of merchandise exports) in Jordan in 1974 to that in 1976?
Your response must be concise. 0.91. What is the ratio of the Imports(as % of merchandise exports) in Kuwait in 1974 to that in 1976?
Offer a very short reply. 0.96. What is the ratio of the Imports(as % of merchandise exports) in Philippines in 1974 to that in 1976?
Keep it short and to the point. 1.08. What is the ratio of the Imports(as % of merchandise exports) in Iraq in 1974 to that in 2000?
Offer a terse response. 8.13. What is the ratio of the Imports(as % of merchandise exports) of Jordan in 1974 to that in 2000?
Ensure brevity in your answer.  0.82. What is the ratio of the Imports(as % of merchandise exports) in Kuwait in 1974 to that in 2000?
Provide a succinct answer. 2.27. What is the ratio of the Imports(as % of merchandise exports) in Philippines in 1974 to that in 2000?
Keep it short and to the point. 0.74. What is the ratio of the Imports(as % of merchandise exports) of Iraq in 1974 to that in 2001?
Keep it short and to the point. 3.69. What is the ratio of the Imports(as % of merchandise exports) in Jordan in 1974 to that in 2001?
Ensure brevity in your answer.  0.87. What is the ratio of the Imports(as % of merchandise exports) in Kuwait in 1974 to that in 2001?
Keep it short and to the point. 2.33. What is the ratio of the Imports(as % of merchandise exports) of Philippines in 1974 to that in 2001?
Offer a very short reply. 0.74. What is the ratio of the Imports(as % of merchandise exports) of Iraq in 1975 to that in 1976?
Your response must be concise. 0.97. What is the ratio of the Imports(as % of merchandise exports) of Jordan in 1975 to that in 1976?
Give a very brief answer. 1.06. What is the ratio of the Imports(as % of merchandise exports) in Kuwait in 1975 to that in 1976?
Keep it short and to the point. 0.99. What is the ratio of the Imports(as % of merchandise exports) of Philippines in 1975 to that in 1976?
Offer a terse response. 1.08. What is the ratio of the Imports(as % of merchandise exports) of Iraq in 1975 to that in 2000?
Provide a succinct answer. 9.61. What is the ratio of the Imports(as % of merchandise exports) of Kuwait in 1975 to that in 2000?
Give a very brief answer. 2.34. What is the ratio of the Imports(as % of merchandise exports) in Philippines in 1975 to that in 2000?
Your response must be concise. 0.74. What is the ratio of the Imports(as % of merchandise exports) of Iraq in 1975 to that in 2001?
Give a very brief answer. 4.37. What is the ratio of the Imports(as % of merchandise exports) of Jordan in 1975 to that in 2001?
Offer a very short reply. 1.01. What is the ratio of the Imports(as % of merchandise exports) of Kuwait in 1975 to that in 2001?
Your answer should be compact. 2.4. What is the ratio of the Imports(as % of merchandise exports) of Philippines in 1975 to that in 2001?
Your response must be concise. 0.74. What is the ratio of the Imports(as % of merchandise exports) of Iraq in 1976 to that in 2000?
Keep it short and to the point. 9.95. What is the ratio of the Imports(as % of merchandise exports) in Jordan in 1976 to that in 2000?
Offer a terse response. 0.9. What is the ratio of the Imports(as % of merchandise exports) in Kuwait in 1976 to that in 2000?
Your answer should be very brief. 2.36. What is the ratio of the Imports(as % of merchandise exports) in Philippines in 1976 to that in 2000?
Keep it short and to the point. 0.68. What is the ratio of the Imports(as % of merchandise exports) in Iraq in 1976 to that in 2001?
Make the answer very short. 4.52. What is the ratio of the Imports(as % of merchandise exports) in Jordan in 1976 to that in 2001?
Provide a short and direct response. 0.95. What is the ratio of the Imports(as % of merchandise exports) of Kuwait in 1976 to that in 2001?
Your answer should be compact. 2.43. What is the ratio of the Imports(as % of merchandise exports) in Philippines in 1976 to that in 2001?
Make the answer very short. 0.68. What is the ratio of the Imports(as % of merchandise exports) of Iraq in 2000 to that in 2001?
Keep it short and to the point. 0.45. What is the ratio of the Imports(as % of merchandise exports) in Jordan in 2000 to that in 2001?
Ensure brevity in your answer.  1.06. What is the ratio of the Imports(as % of merchandise exports) of Kuwait in 2000 to that in 2001?
Make the answer very short. 1.03. What is the ratio of the Imports(as % of merchandise exports) of Philippines in 2000 to that in 2001?
Provide a succinct answer. 1. What is the difference between the highest and the second highest Imports(as % of merchandise exports) in Iraq?
Offer a terse response. 2.78. What is the difference between the highest and the second highest Imports(as % of merchandise exports) of Jordan?
Your response must be concise. 3.31. What is the difference between the highest and the second highest Imports(as % of merchandise exports) of Kuwait?
Your response must be concise. 0.86. What is the difference between the highest and the second highest Imports(as % of merchandise exports) in Philippines?
Provide a succinct answer. 0.27. What is the difference between the highest and the lowest Imports(as % of merchandise exports) of Iraq?
Your answer should be very brief. 72.99. What is the difference between the highest and the lowest Imports(as % of merchandise exports) of Jordan?
Make the answer very short. 18.46. What is the difference between the highest and the lowest Imports(as % of merchandise exports) in Kuwait?
Give a very brief answer. 47.66. What is the difference between the highest and the lowest Imports(as % of merchandise exports) of Philippines?
Make the answer very short. 24.92. 